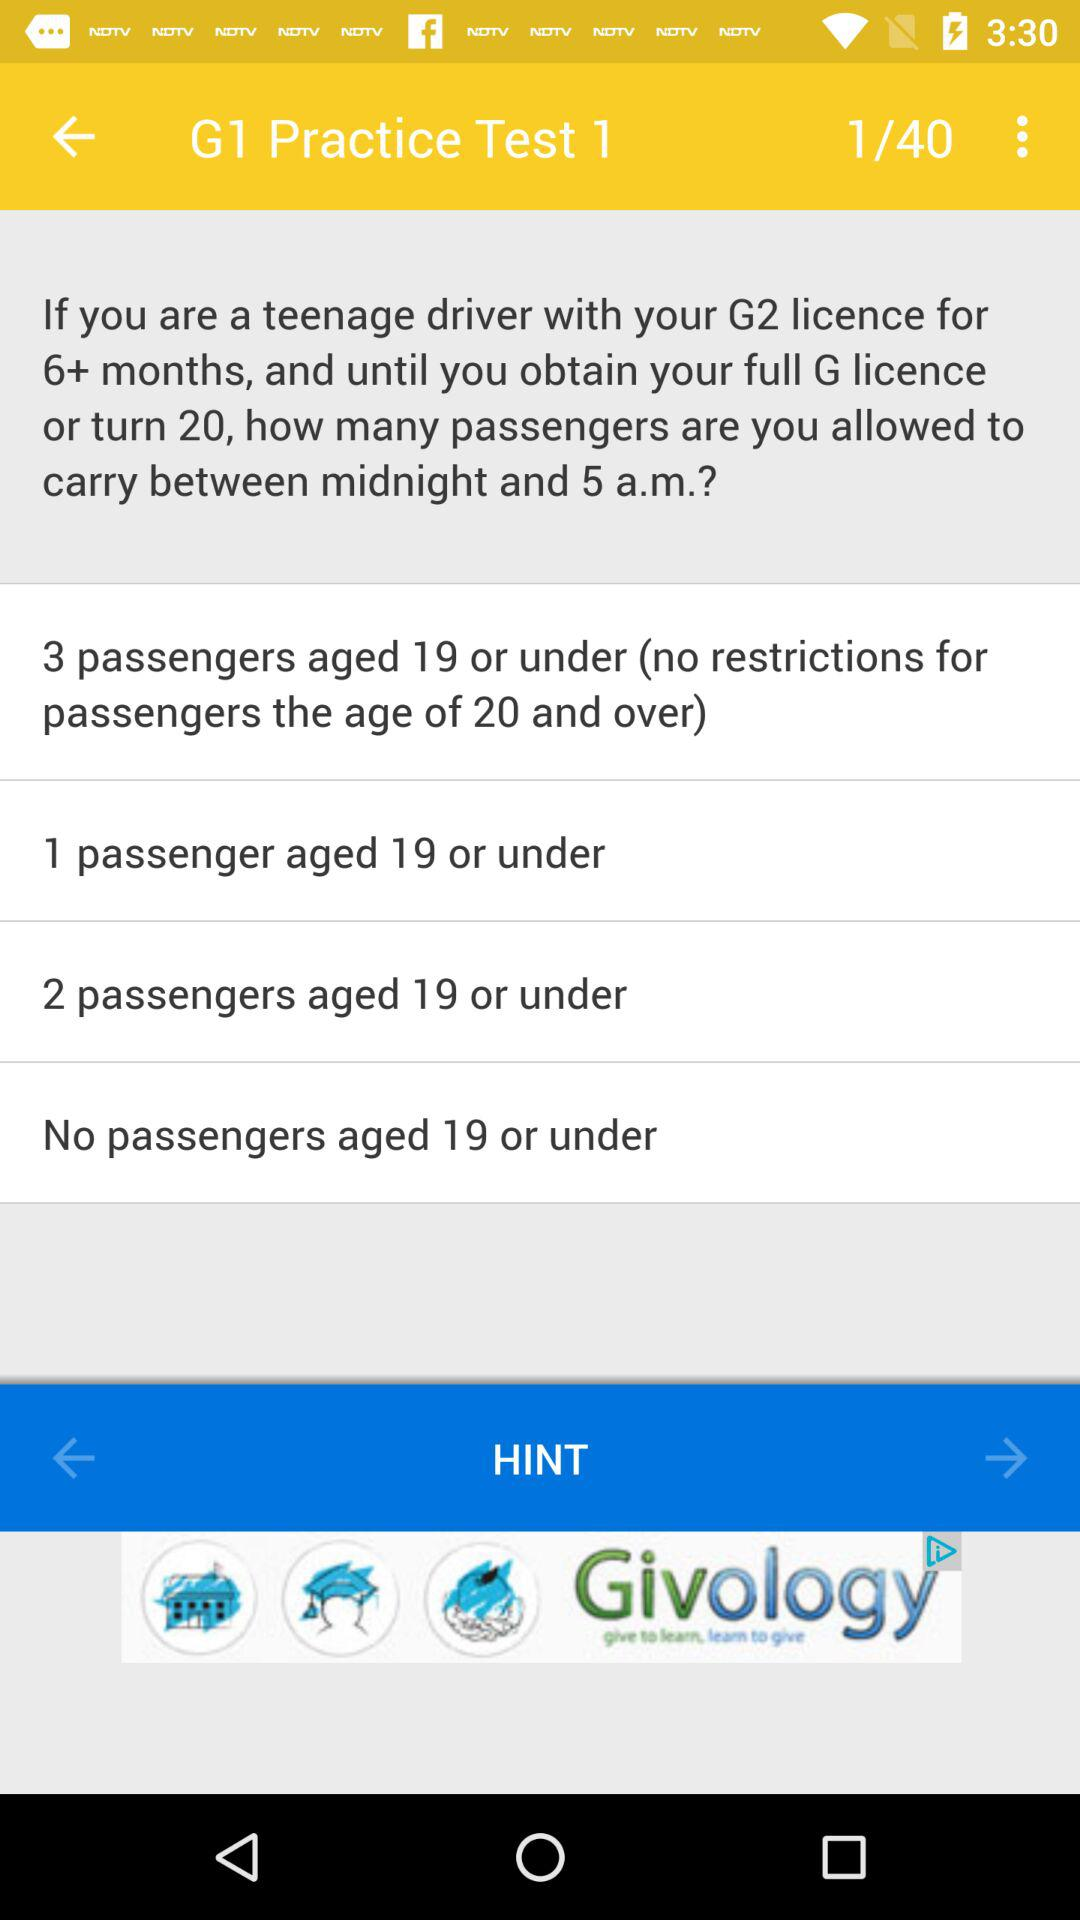Currently, we are on which page number of the "G1 Practice Test 1"? Currently, you are on page number 1. 